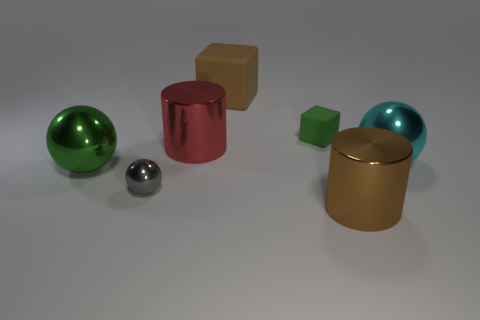Do the green ball and the large brown block have the same material?
Make the answer very short. No. How many small blocks are the same material as the big green sphere?
Provide a succinct answer. 0. There is a small thing that is made of the same material as the big green sphere; what color is it?
Offer a terse response. Gray. What is the shape of the gray object?
Give a very brief answer. Sphere. What is the material of the big sphere on the left side of the cyan metallic object?
Your answer should be very brief. Metal. Are there any cylinders of the same color as the large block?
Make the answer very short. Yes. There is a brown metallic object that is the same size as the red thing; what is its shape?
Provide a succinct answer. Cylinder. There is a tiny object behind the big red object; what color is it?
Your answer should be compact. Green. Are there any blocks that are in front of the large cylinder that is right of the red metal cylinder?
Ensure brevity in your answer.  No. How many objects are big metal things that are on the left side of the red cylinder or small red cylinders?
Your response must be concise. 1. 